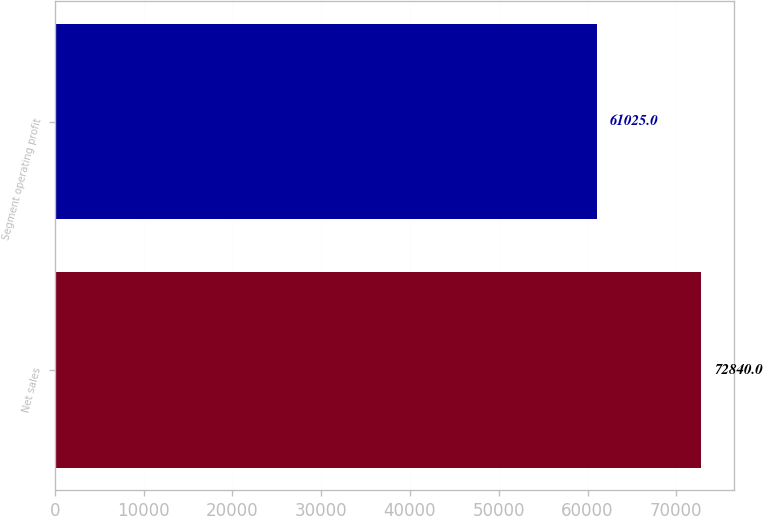<chart> <loc_0><loc_0><loc_500><loc_500><bar_chart><fcel>Net sales<fcel>Segment operating profit<nl><fcel>72840<fcel>61025<nl></chart> 